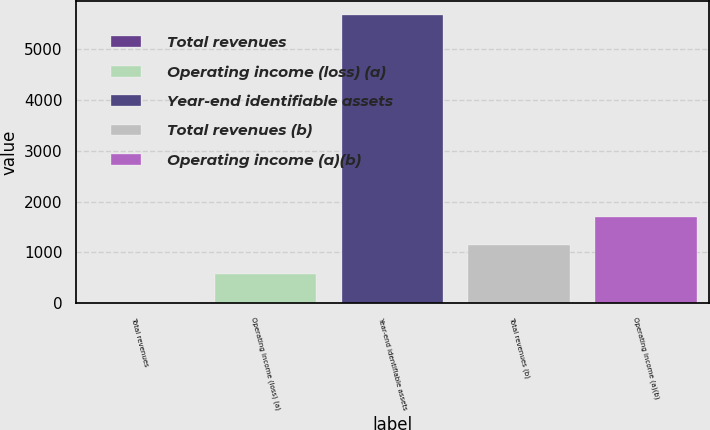Convert chart to OTSL. <chart><loc_0><loc_0><loc_500><loc_500><bar_chart><fcel>Total revenues<fcel>Operating income (loss) (a)<fcel>Year-end identifiable assets<fcel>Total revenues (b)<fcel>Operating income (a)(b)<nl><fcel>7<fcel>572.2<fcel>5659<fcel>1137.4<fcel>1702.6<nl></chart> 